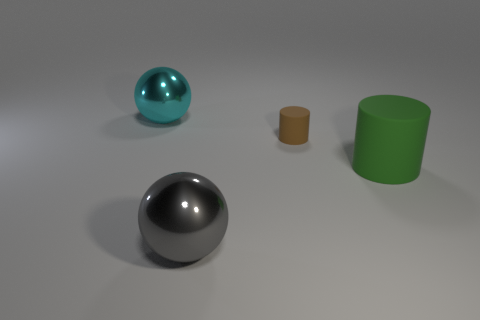The sphere that is to the left of the shiny object right of the large cyan thing is made of what material?
Ensure brevity in your answer.  Metal. Do the cyan sphere and the brown thing have the same size?
Your answer should be compact. No. What number of things are shiny spheres that are on the left side of the gray shiny sphere or big yellow metallic cylinders?
Offer a very short reply. 1. There is a object that is in front of the matte object that is in front of the brown rubber object; what shape is it?
Your response must be concise. Sphere. There is a green object; is its size the same as the shiny sphere that is in front of the small brown cylinder?
Make the answer very short. Yes. What is the sphere in front of the large cyan metal sphere made of?
Offer a very short reply. Metal. What number of things are in front of the brown cylinder and right of the gray metal object?
Your answer should be compact. 1. What is the material of the gray object that is the same size as the green matte cylinder?
Provide a succinct answer. Metal. There is a object that is on the left side of the large gray metallic thing; is its size the same as the thing that is in front of the big matte cylinder?
Ensure brevity in your answer.  Yes. Are there any green cylinders right of the gray thing?
Ensure brevity in your answer.  Yes. 